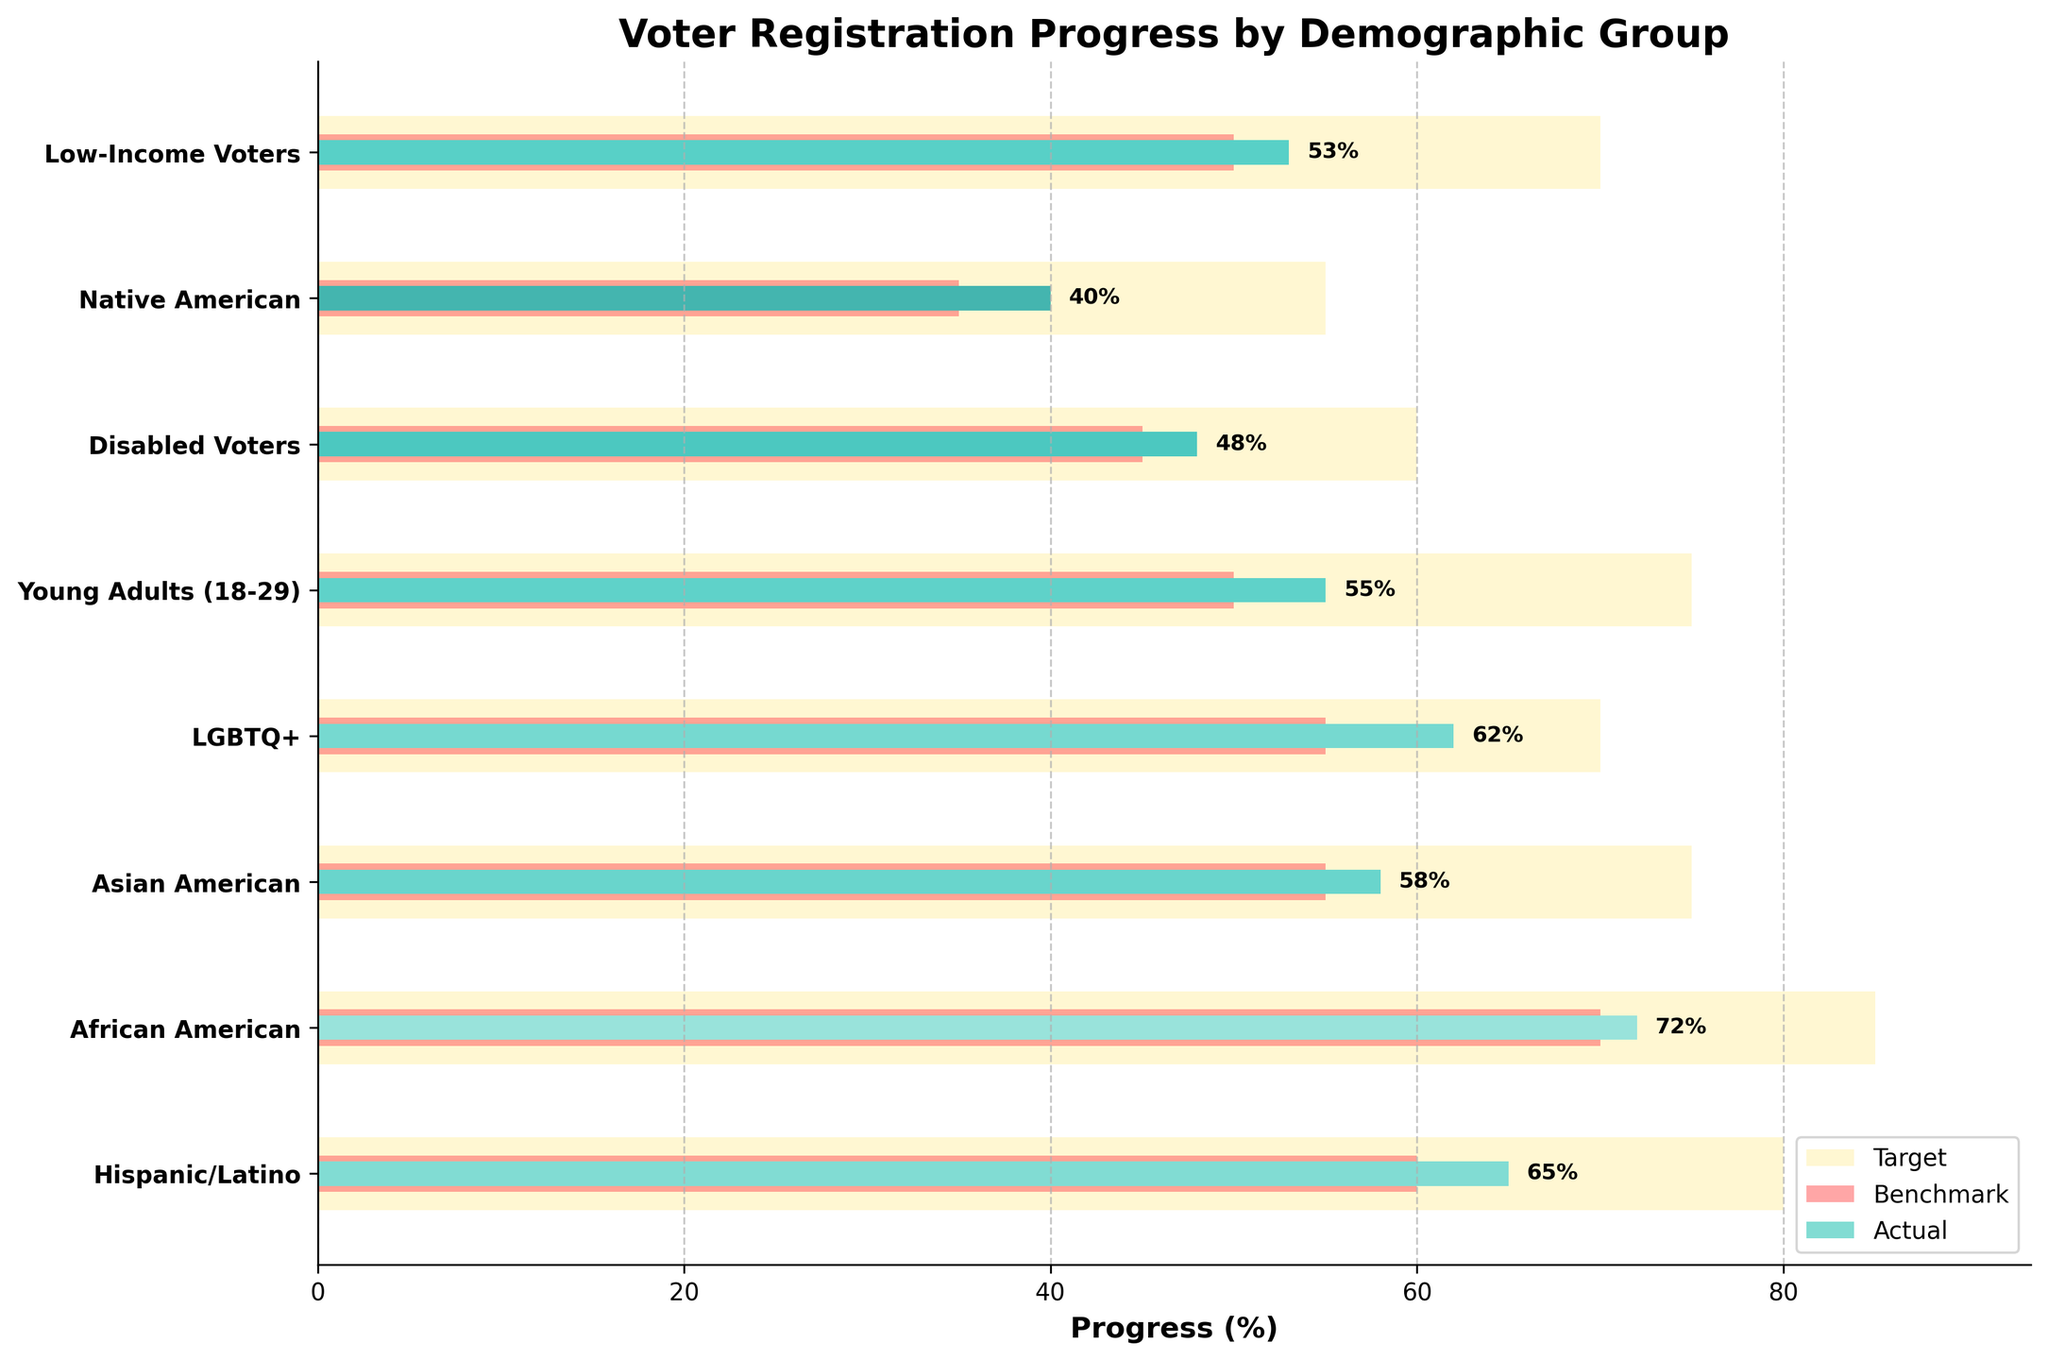What is the title of the chart? The title is displayed at the top of the chart, which is a prominent text element.
Answer: Voter Registration Progress by Demographic Group Which demographic group has the highest actual registration percentage? By examining the bars representing actual registrations, the highest value can be identified.
Answer: African American What is the actual registration percentage for Young Adults (18-29)? Locate the Young Adults (18-29) category and read the corresponding bar representing actual registration.
Answer: 55% How many demographic groups have an actual registration percentage above their benchmark but below their target? Compare actual registration percentages with both target and benchmark values for each demographic group. Count how many groups meet the criteria.
Answer: 6 Which group has the lowest actual registration percentage, and what is it? Identify the shortest bar representing actual registration percentages to find the lowest value.
Answer: Native American, 40% Is the actual registration for Hispanic/Latino above or below the benchmark? Compare the actual registration bar for Hispanic/Latino with its associated benchmark bar.
Answer: Above Which demographic shows the largest gap between the target and actual registration percentages? Calculate the difference between target and actual registration percentages for each group and find the maximum.
Answer: Young Adults (18-29) How does the actual registration for Disabled Voters compare to the target registration percentage? Compare the actual registration percentage bar for Disabled Voters with its target registration percentage bar.
Answer: Below What is the difference in actual registration between Low-Income Voters and Native American? Subtract the actual registration percentage of Native American from that of Low-Income Voters.
Answer: 13% Which demographic group's actual registration percentage matches precisely with its benchmark? Identify the groups where the actual registration bar aligns exactly with the benchmark bar.
Answer: None 